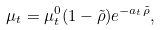Convert formula to latex. <formula><loc_0><loc_0><loc_500><loc_500>\mu _ { t } = \mu ^ { 0 } _ { t } ( 1 - \tilde { \rho } ) e ^ { - a _ { t } \tilde { \rho } } ,</formula> 